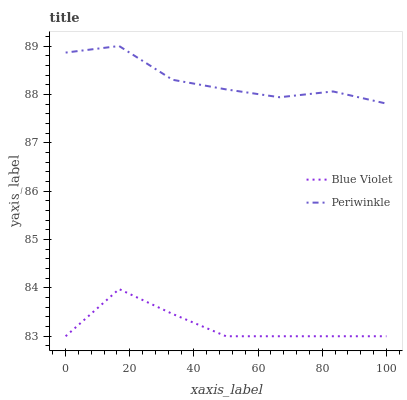Does Blue Violet have the maximum area under the curve?
Answer yes or no. No. Is Blue Violet the roughest?
Answer yes or no. No. Does Blue Violet have the highest value?
Answer yes or no. No. Is Blue Violet less than Periwinkle?
Answer yes or no. Yes. Is Periwinkle greater than Blue Violet?
Answer yes or no. Yes. Does Blue Violet intersect Periwinkle?
Answer yes or no. No. 